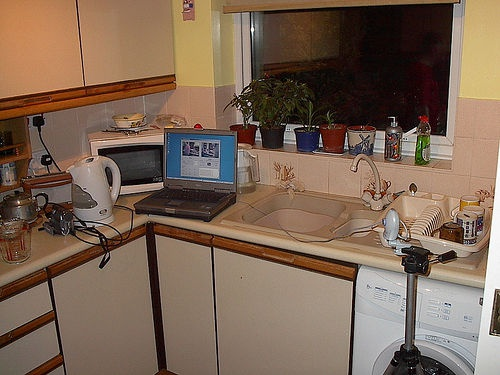Describe the objects in this image and their specific colors. I can see laptop in salmon, black, gray, and blue tones, microwave in salmon, black, gray, and darkgray tones, sink in salmon, gray, brown, and tan tones, potted plant in salmon, black, darkgreen, and gray tones, and potted plant in salmon, black, navy, gray, and darkgreen tones in this image. 